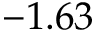Convert formula to latex. <formula><loc_0><loc_0><loc_500><loc_500>- 1 . 6 3</formula> 